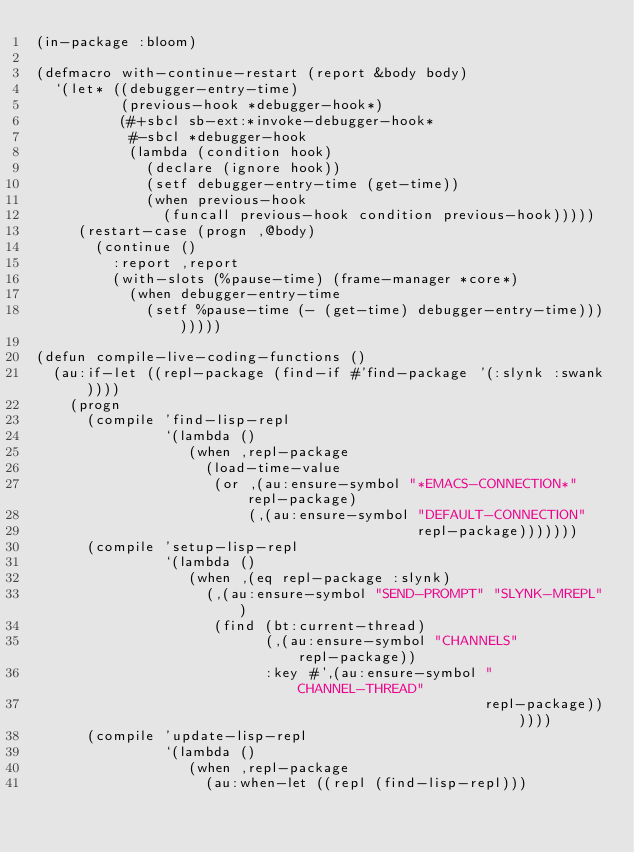<code> <loc_0><loc_0><loc_500><loc_500><_Lisp_>(in-package :bloom)

(defmacro with-continue-restart (report &body body)
  `(let* ((debugger-entry-time)
          (previous-hook *debugger-hook*)
          (#+sbcl sb-ext:*invoke-debugger-hook*
           #-sbcl *debugger-hook
           (lambda (condition hook)
             (declare (ignore hook))
             (setf debugger-entry-time (get-time))
             (when previous-hook
               (funcall previous-hook condition previous-hook)))))
     (restart-case (progn ,@body)
       (continue ()
         :report ,report
         (with-slots (%pause-time) (frame-manager *core*)
           (when debugger-entry-time
             (setf %pause-time (- (get-time) debugger-entry-time))))))))

(defun compile-live-coding-functions ()
  (au:if-let ((repl-package (find-if #'find-package '(:slynk :swank))))
    (progn
      (compile 'find-lisp-repl
               `(lambda ()
                  (when ,repl-package
                    (load-time-value
                     (or ,(au:ensure-symbol "*EMACS-CONNECTION*" repl-package)
                         (,(au:ensure-symbol "DEFAULT-CONNECTION"
                                             repl-package)))))))
      (compile 'setup-lisp-repl
               `(lambda ()
                  (when ,(eq repl-package :slynk)
                    (,(au:ensure-symbol "SEND-PROMPT" "SLYNK-MREPL")
                     (find (bt:current-thread)
                           (,(au:ensure-symbol "CHANNELS" repl-package))
                           :key #',(au:ensure-symbol "CHANNEL-THREAD"
                                                     repl-package))))))
      (compile 'update-lisp-repl
               `(lambda ()
                  (when ,repl-package
                    (au:when-let ((repl (find-lisp-repl)))</code> 